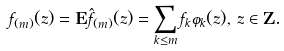Convert formula to latex. <formula><loc_0><loc_0><loc_500><loc_500>f _ { ( m ) } ( z ) = \mathbf E \hat { f } _ { ( m ) } ( z ) = \sum _ { k \leq m } f _ { k } \varphi _ { k } ( z ) , \, z \in \mathbf Z .</formula> 